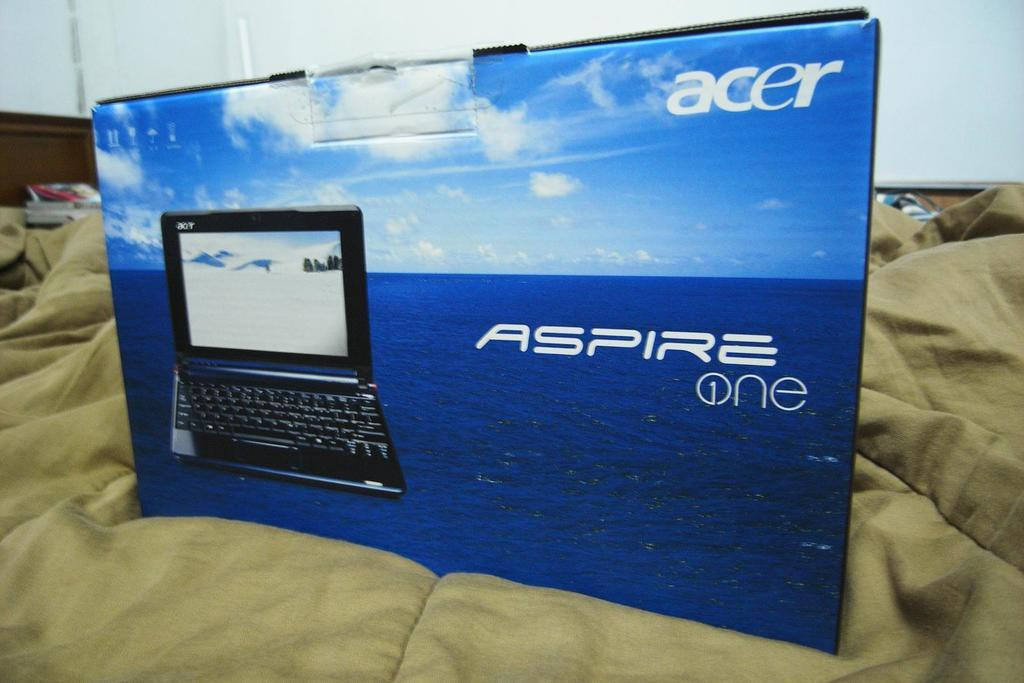<image>
Create a compact narrative representing the image presented. An Acer laptop is visible on a blue box. 